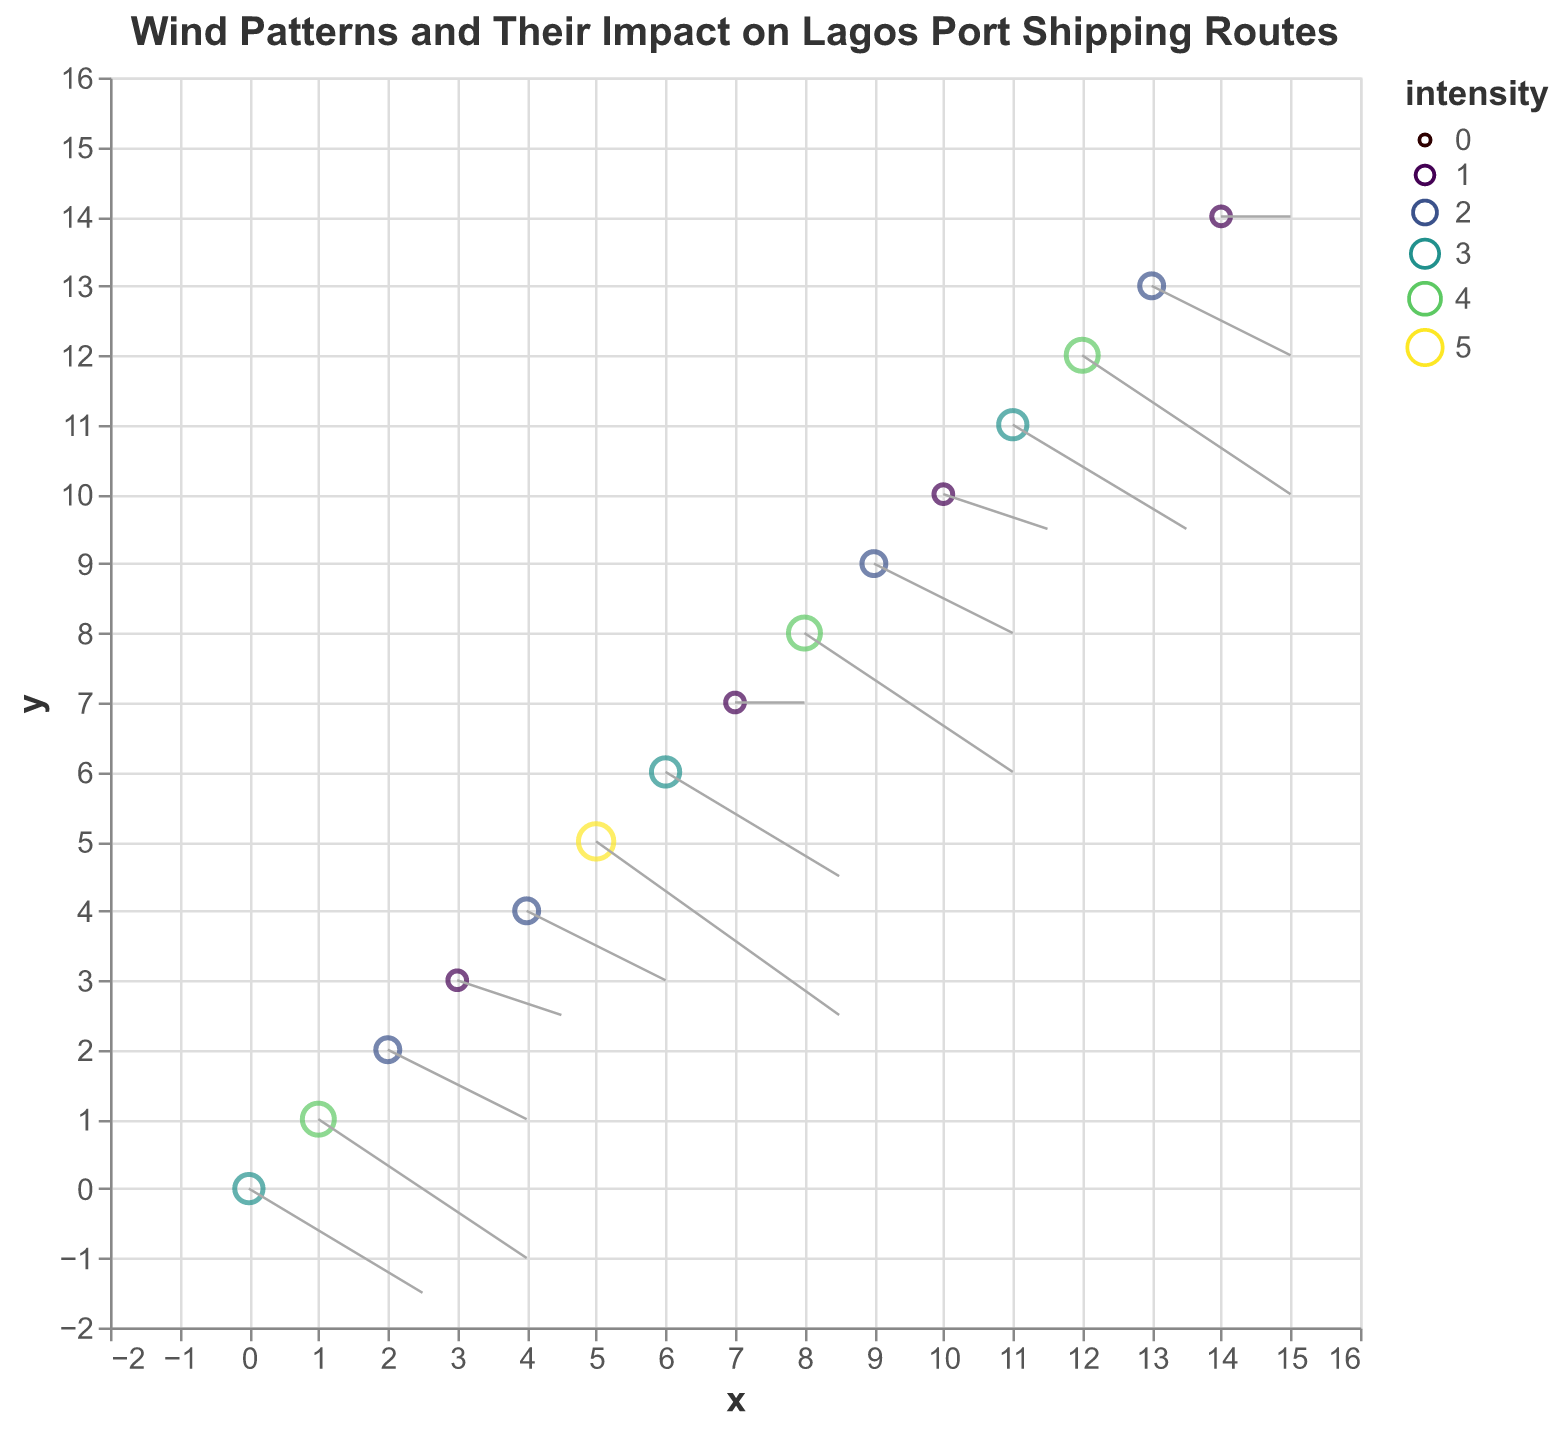What's the title of the plot? The title is usually located at the top of the plot and it provides a brief description of the data and the insight the plot is trying to illustrate. In this case, the title is clearly shown at the top of the quiver plot.
Answer: "Wind Patterns and Their Impact on Lagos Port Shipping Routes" What do the colors on the plot represent? The legend or the plot's description usually indicates the meaning of the colors. Here, the colors range from light to dark, representing different levels of wind intensity as measured on the scale.
Answer: Wind Intensity How many data points show the highest wind intensity on the plot? By looking at the size and color of the points, we see that they vary in intensity. The largest and darkest points represent the highest intensity. There is only one such point in the plot, at coordinate (5,5) with an intensity of 5.
Answer: 1 Which point has the least wind intensity and what is its value? The smallest and lightest colored point represents the least wind intensity. On this plot, the point at (3,3) and (7,7) both have the smallest size and lightest color indicating an intensity of 1.
Answer: (3,3) and (7,7) with intensity 1 What is the general direction of the wind at the point (10, 10)? The direction is shown by the arrows, with the coordinates indicating the start point. For the point at (10, 10), the arrow points leftwards and slightly upwards, implying a west and slightly north direction.
Answer: West and slightly north How does the wind intensity at point (0,0) compare to the wind intensity at point (5,5)? By checking both points, the intensity at (0,0) is 3, and at (5,5) it is 5. Therefore, the wind intensity at (5,5) is higher.
Answer: Higher at (5,5) At which coordinates do we observe the most significant change in wind intensity? The most significant change in wind intensity would be observed by looking for the extremes. The largest change is from (5,5) to any of its neighbors. Comparing intensity of 5 at (5,5) and its neighbor (6,6) which has intensity 3, we have the difference of 2.
Answer: Between (5,5) and (6,6) In which general direction do most of the winds tend to blow? Examining the direction of the arrows across the plot, the majority appear to point towards the west or left side, indicating a general westward direction for most of the winds.
Answer: Westward What is the Euclidean distance between the points (0,0) and (5,5)? The Euclidean distance in a Cartesian plane is calculated using the formula sqrt((x2 - x1)^2 + (y2 - y1)^2). Here, x1=0, y1=0, x2=5, y2=5: sqrt((5-0)^2 + (5-0)^2) = sqrt(25 + 25) = sqrt(50) = 7.07
Answer: 7.07 